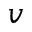<formula> <loc_0><loc_0><loc_500><loc_500>v</formula> 